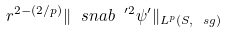Convert formula to latex. <formula><loc_0><loc_0><loc_500><loc_500>r ^ { 2 - ( 2 / p ) } \| \ s n a b ^ { \ \prime 2 } \psi ^ { \prime } \| _ { L ^ { p } ( S , \ s g ) }</formula> 